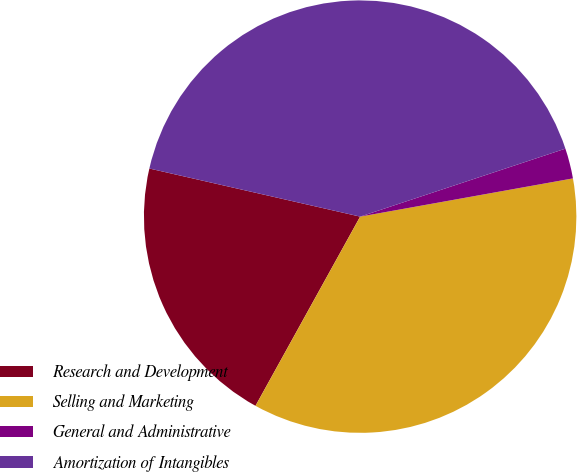<chart> <loc_0><loc_0><loc_500><loc_500><pie_chart><fcel>Research and Development<fcel>Selling and Marketing<fcel>General and Administrative<fcel>Amortization of Intangibles<nl><fcel>20.53%<fcel>35.87%<fcel>2.26%<fcel>41.34%<nl></chart> 